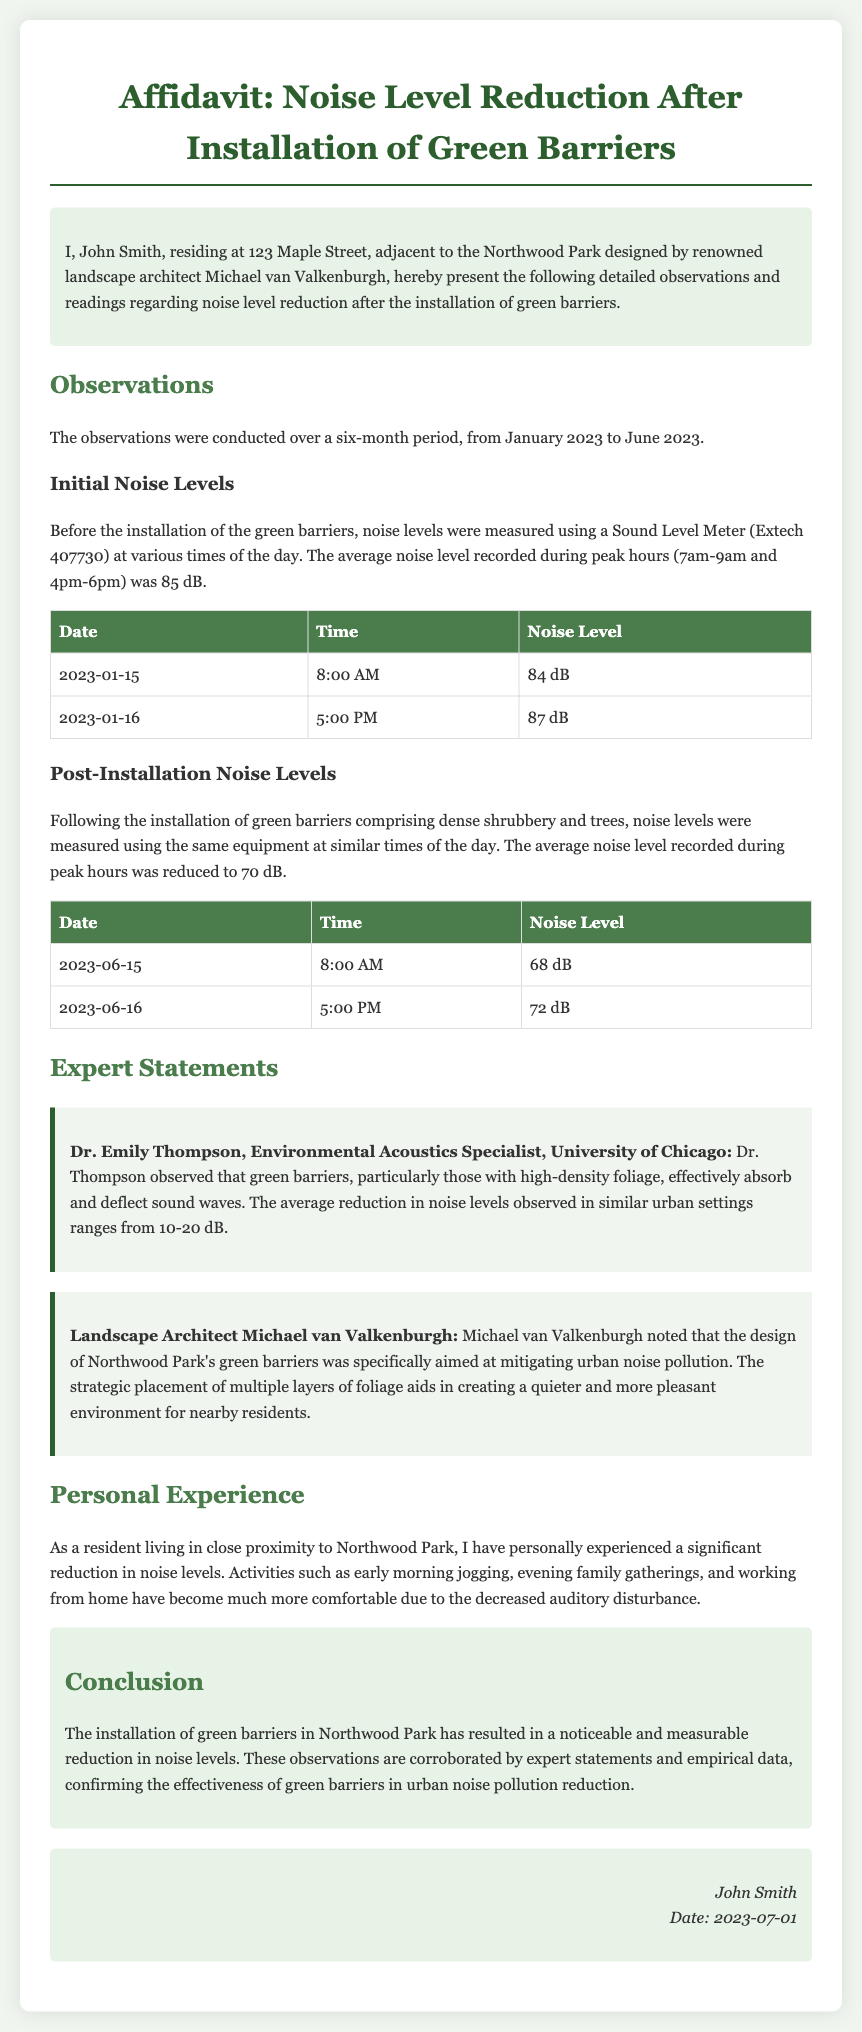What is the name of the resident presenting the affidavit? The affidavit is presented by John Smith, who resides at 123 Maple Street.
Answer: John Smith What are the initial average noise levels before the installation? The average noise level recorded during peak hours before installation was 85 dB.
Answer: 85 dB What date was the post-installation noise level measured for 68 dB? The 68 dB noise level was measured on June 15, 2023, at 8:00 AM.
Answer: June 15, 2023 Who is the Environmental Acoustics Specialist mentioned in the document? The expert mentioned is Dr. Emily Thompson, who is affiliated with the University of Chicago.
Answer: Dr. Emily Thompson What was the recorded noise level on January 16, 2023? The noise level recorded on that date at 5:00 PM was 87 dB.
Answer: 87 dB How much was the average reduction in noise levels observed? The average reduction in noise levels observed in similar settings ranges from 10-20 dB according to the expert statements.
Answer: 10-20 dB What conclusion is drawn about the effectiveness of the green barriers? The affidavit concludes that the installation of green barriers has resulted in a noticeable and measurable reduction in noise levels.
Answer: Noticeable and measurable reduction What is the date of the resident's signature on the affidavit? The date of the resident's signature is July 1, 2023.
Answer: July 1, 2023 What specific design goal did Michael van Valkenburgh mention for the green barriers? Michael van Valkenburgh aimed to mitigate urban noise pollution with the design of the green barriers.
Answer: Mitigating urban noise pollution 